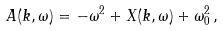Convert formula to latex. <formula><loc_0><loc_0><loc_500><loc_500>A ( k , \omega ) = - \omega ^ { 2 } + X ( k , \omega ) + \omega _ { 0 } ^ { 2 } \, ,</formula> 